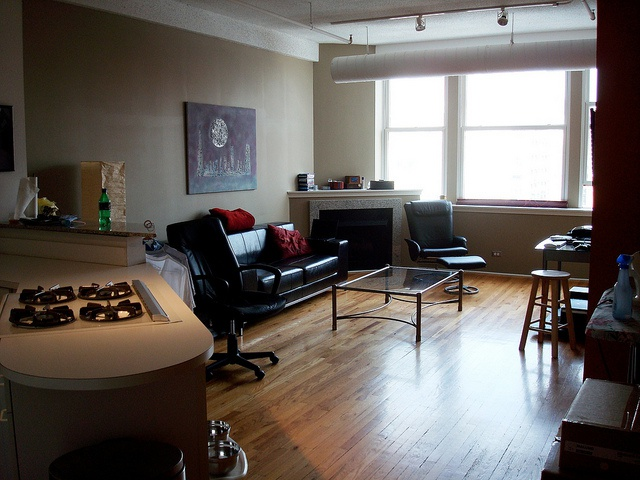Describe the objects in this image and their specific colors. I can see chair in black, gray, navy, and blue tones, oven in black, maroon, and gray tones, couch in black, lightblue, maroon, and gray tones, chair in black, gray, lightblue, and darkblue tones, and chair in black, maroon, darkgray, and gray tones in this image. 